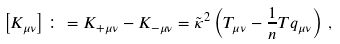Convert formula to latex. <formula><loc_0><loc_0><loc_500><loc_500>\left [ K _ { \mu \nu } \right ] \colon = K _ { + \mu \nu } - K _ { - \mu \nu } = \tilde { \kappa } ^ { 2 } \left ( T _ { \mu \nu } - \frac { 1 } { n } T q _ { \mu \nu } \right ) \, ,</formula> 